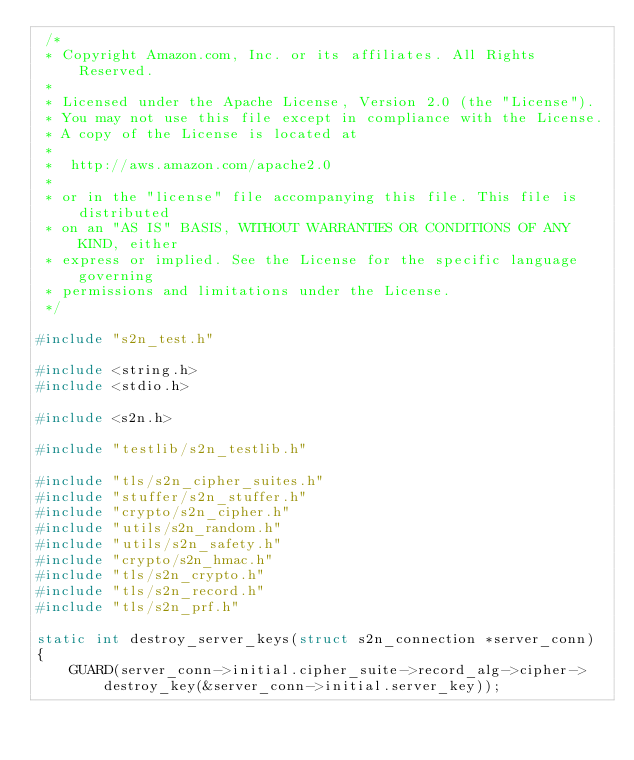<code> <loc_0><loc_0><loc_500><loc_500><_C_> /*
 * Copyright Amazon.com, Inc. or its affiliates. All Rights Reserved.
 *
 * Licensed under the Apache License, Version 2.0 (the "License").
 * You may not use this file except in compliance with the License.
 * A copy of the License is located at
 *
 *  http://aws.amazon.com/apache2.0
 *
 * or in the "license" file accompanying this file. This file is distributed
 * on an "AS IS" BASIS, WITHOUT WARRANTIES OR CONDITIONS OF ANY KIND, either
 * express or implied. See the License for the specific language governing
 * permissions and limitations under the License.
 */

#include "s2n_test.h"

#include <string.h>
#include <stdio.h>

#include <s2n.h>

#include "testlib/s2n_testlib.h"

#include "tls/s2n_cipher_suites.h"
#include "stuffer/s2n_stuffer.h"
#include "crypto/s2n_cipher.h"
#include "utils/s2n_random.h"
#include "utils/s2n_safety.h"
#include "crypto/s2n_hmac.h"
#include "tls/s2n_crypto.h"
#include "tls/s2n_record.h"
#include "tls/s2n_prf.h"

static int destroy_server_keys(struct s2n_connection *server_conn)
{
    GUARD(server_conn->initial.cipher_suite->record_alg->cipher->destroy_key(&server_conn->initial.server_key));</code> 